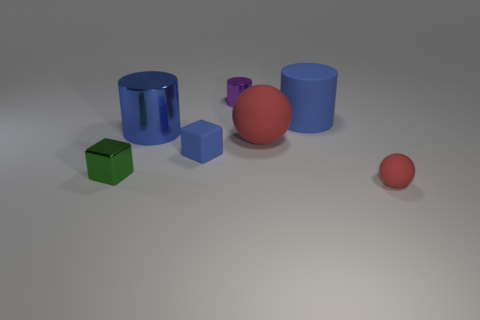How many objects in the image have a circular base? In the image, there are two objects that have a circular base. The first object is the large blue cylinder, and the second is the smaller purple cylinder. 